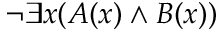Convert formula to latex. <formula><loc_0><loc_0><loc_500><loc_500>\neg \exists x ( A ( x ) \land B ( x ) )</formula> 